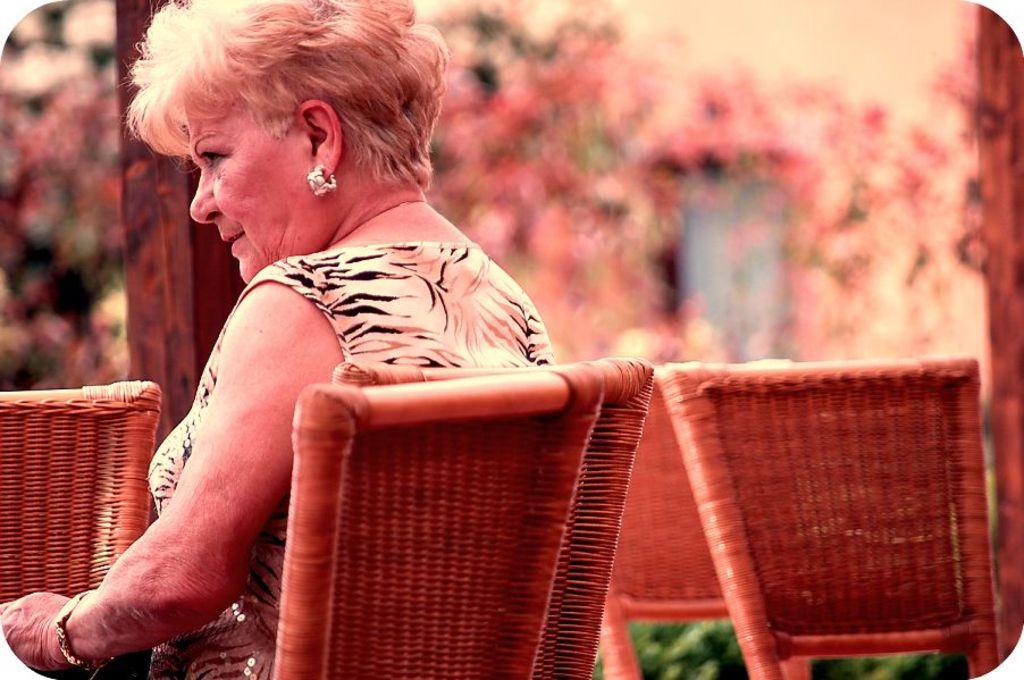Who is the main subject in the image? There is a woman in the image. What is the woman doing in the image? The woman is sitting on a chair. How many chairs are visible in the image? There are chairs in the image. Can you describe the background of the image? The background of the image is blurred. What type of cake is the woman looking at in the image? There is no cake present in the image, and the woman is not looking at anything specific. 